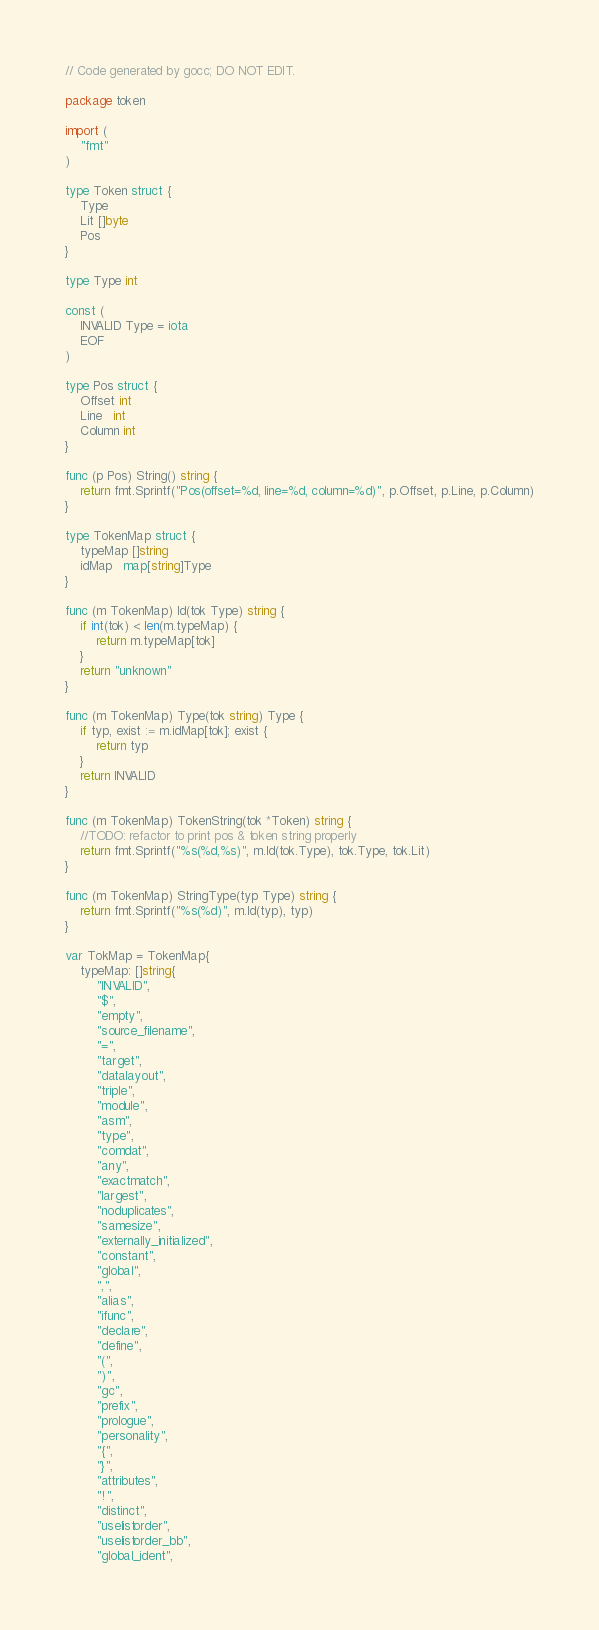<code> <loc_0><loc_0><loc_500><loc_500><_Go_>// Code generated by gocc; DO NOT EDIT.

package token

import (
	"fmt"
)

type Token struct {
	Type
	Lit []byte
	Pos
}

type Type int

const (
	INVALID Type = iota
	EOF
)

type Pos struct {
	Offset int
	Line   int
	Column int
}

func (p Pos) String() string {
	return fmt.Sprintf("Pos(offset=%d, line=%d, column=%d)", p.Offset, p.Line, p.Column)
}

type TokenMap struct {
	typeMap []string
	idMap   map[string]Type
}

func (m TokenMap) Id(tok Type) string {
	if int(tok) < len(m.typeMap) {
		return m.typeMap[tok]
	}
	return "unknown"
}

func (m TokenMap) Type(tok string) Type {
	if typ, exist := m.idMap[tok]; exist {
		return typ
	}
	return INVALID
}

func (m TokenMap) TokenString(tok *Token) string {
	//TODO: refactor to print pos & token string properly
	return fmt.Sprintf("%s(%d,%s)", m.Id(tok.Type), tok.Type, tok.Lit)
}

func (m TokenMap) StringType(typ Type) string {
	return fmt.Sprintf("%s(%d)", m.Id(typ), typ)
}

var TokMap = TokenMap{
	typeMap: []string{
		"INVALID",
		"$",
		"empty",
		"source_filename",
		"=",
		"target",
		"datalayout",
		"triple",
		"module",
		"asm",
		"type",
		"comdat",
		"any",
		"exactmatch",
		"largest",
		"noduplicates",
		"samesize",
		"externally_initialized",
		"constant",
		"global",
		",",
		"alias",
		"ifunc",
		"declare",
		"define",
		"(",
		")",
		"gc",
		"prefix",
		"prologue",
		"personality",
		"{",
		"}",
		"attributes",
		"!",
		"distinct",
		"uselistorder",
		"uselistorder_bb",
		"global_ident",</code> 